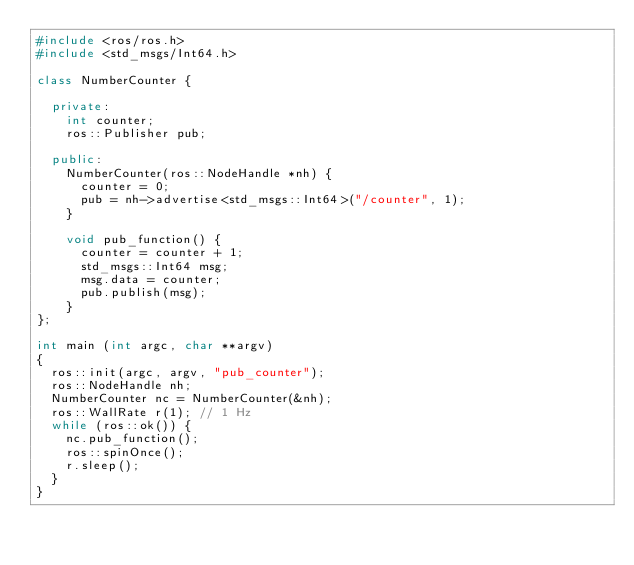Convert code to text. <code><loc_0><loc_0><loc_500><loc_500><_C++_>#include <ros/ros.h>
#include <std_msgs/Int64.h>

class NumberCounter {

  private:
    int counter;
    ros::Publisher pub;
  
  public:
    NumberCounter(ros::NodeHandle *nh) {
      counter = 0;
      pub = nh->advertise<std_msgs::Int64>("/counter", 1);    
    }
  
    void pub_function() {
      counter = counter + 1;
      std_msgs::Int64 msg;
      msg.data = counter;
      pub.publish(msg);
    }
};

int main (int argc, char **argv)
{
  ros::init(argc, argv, "pub_counter");
  ros::NodeHandle nh;
  NumberCounter nc = NumberCounter(&nh);
  ros::WallRate r(1); // 1 Hz
  while (ros::ok()) {
    nc.pub_function();
    ros::spinOnce();
    r.sleep();
  }
}
</code> 